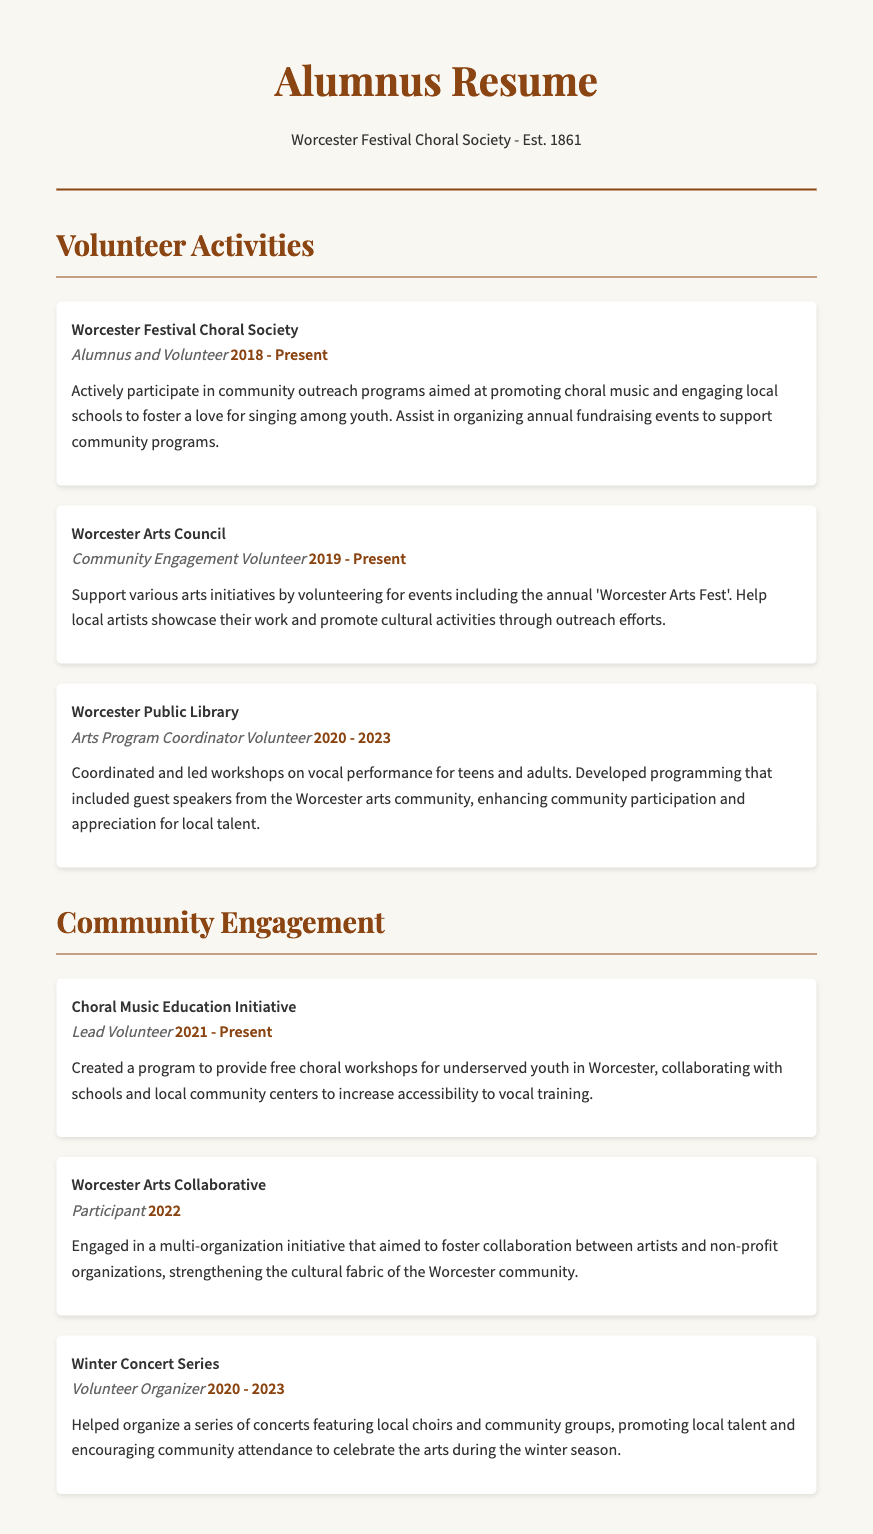what is the role of the individual in the Worcester Festival Choral Society? The individual is an Alumnus and Volunteer in the Worcester Festival Choral Society.
Answer: Alumnus and Volunteer what year did the individual start volunteering for the Worcester Arts Council? The individual started volunteering for the Worcester Arts Council in 2019.
Answer: 2019 how many years did the individual volunteer at the Worcester Public Library? The individual volunteered at the Worcester Public Library from 2020 to 2023, which is 3 years.
Answer: 3 years what initiative did the individual create for underserved youth? The individual created the Choral Music Education Initiative to provide free choral workshops.
Answer: Choral Music Education Initiative what role did the individual have in the Winter Concert Series? The individual served as a Volunteer Organizer for the Winter Concert Series.
Answer: Volunteer Organizer which community engagement activity involved collaboration with schools and local community centers? The Choral Music Education Initiative involved collaboration with schools and local community centers.
Answer: Choral Music Education Initiative how many volunteer roles are listed in the document? There are five volunteer roles listed in the document.
Answer: five what was the focus of the Worcester Arts Collaborative project? The focus was to foster collaboration between artists and non-profit organizations.
Answer: collaboration between artists and non-profit organizations 